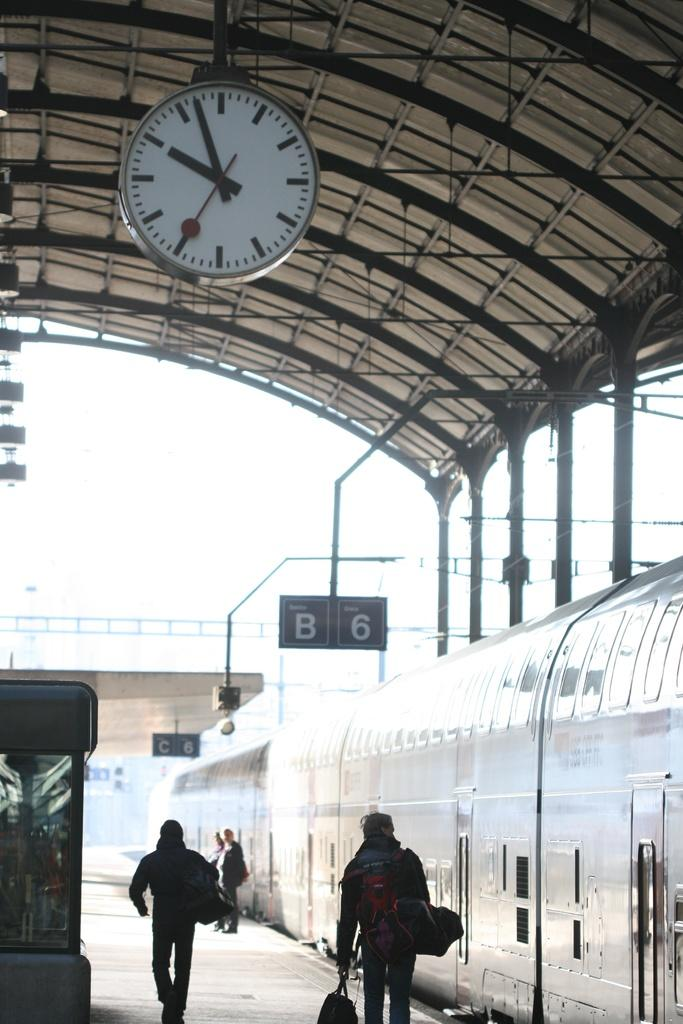<image>
Present a compact description of the photo's key features. A train platform is labelled as B6, according to a sign above the train. 